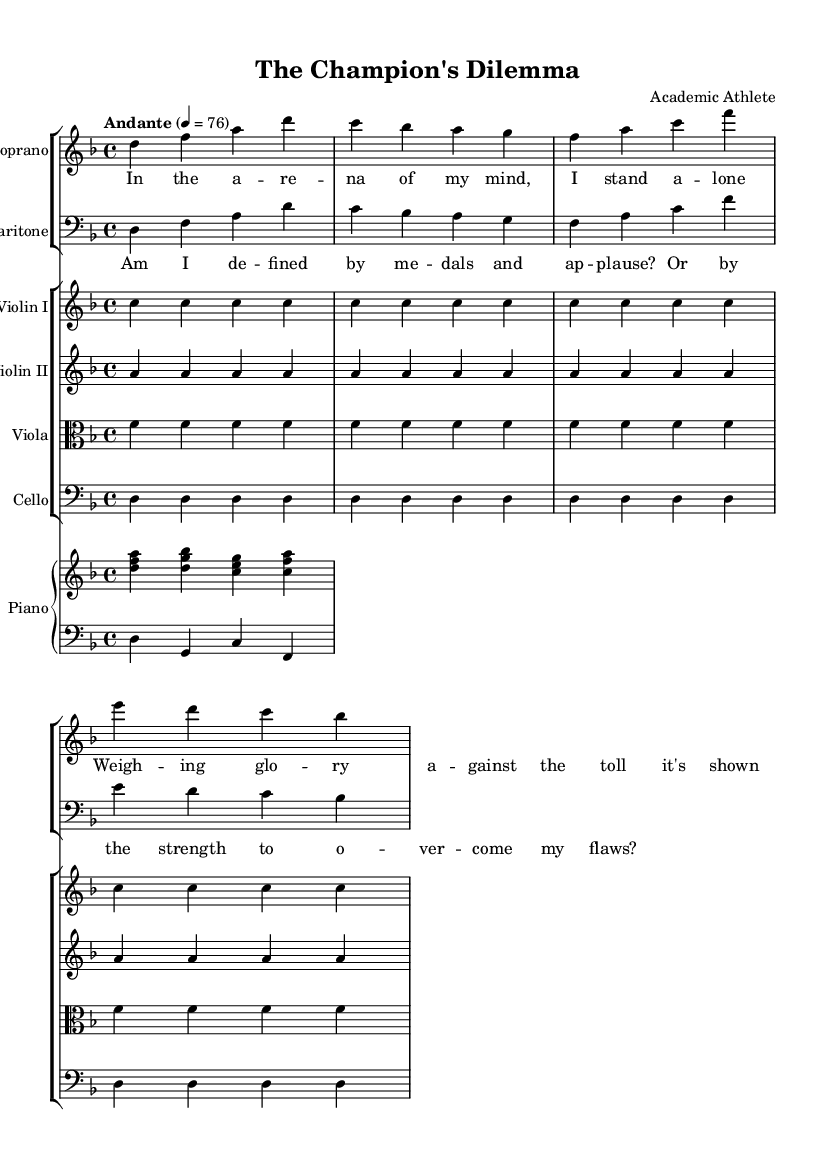What is the key signature of this music? The key signature is indicated by the number of sharps or flats that are notated at the beginning of the staff. In this case, there are two flats (B and E) in the key signature of D minor.
Answer: D minor What is the time signature of this music? The time signature is found at the beginning of the staff and indicates how many beats are in each measure. Here, the time signature is 4/4, meaning there are four beats per measure.
Answer: 4/4 What is the tempo marking for this piece? The tempo marking is usually found below the title and indicates the speed of the music. In this case, the tempo is marked as "Andante," which suggests a moderate pace.
Answer: Andante How many measures are in the soprano part? The number of measures in the soprano part can be counted by looking at the section of music designated for the soprano voice. In this instance, there are four measures of music for the soprano.
Answer: Four What lyrics accompany the chorus section? The lyrics for the chorus section can be found beneath the corresponding music line and indicate what will be sung. The chorus lyrics are "Am I defined by medals and applause? Or by the strength to overcome my flaws?"
Answer: Am I defined by medals and applause? Or by the strength to overcome my flaws? What instruments are included in the orchestra? The instruments in the orchestra can be identified by looking at the different staves. This piece includes Soprano, Baritone, Violin I, Violin II, Viola, Cello, and Piano.
Answer: Soprano, Baritone, Violin I, Violin II, Viola, Cello, Piano 